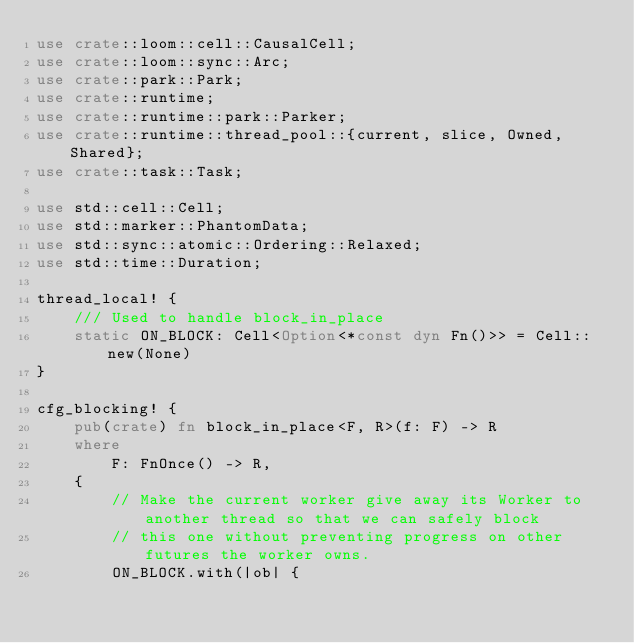Convert code to text. <code><loc_0><loc_0><loc_500><loc_500><_Rust_>use crate::loom::cell::CausalCell;
use crate::loom::sync::Arc;
use crate::park::Park;
use crate::runtime;
use crate::runtime::park::Parker;
use crate::runtime::thread_pool::{current, slice, Owned, Shared};
use crate::task::Task;

use std::cell::Cell;
use std::marker::PhantomData;
use std::sync::atomic::Ordering::Relaxed;
use std::time::Duration;

thread_local! {
    /// Used to handle block_in_place
    static ON_BLOCK: Cell<Option<*const dyn Fn()>> = Cell::new(None)
}

cfg_blocking! {
    pub(crate) fn block_in_place<F, R>(f: F) -> R
    where
        F: FnOnce() -> R,
    {
        // Make the current worker give away its Worker to another thread so that we can safely block
        // this one without preventing progress on other futures the worker owns.
        ON_BLOCK.with(|ob| {</code> 